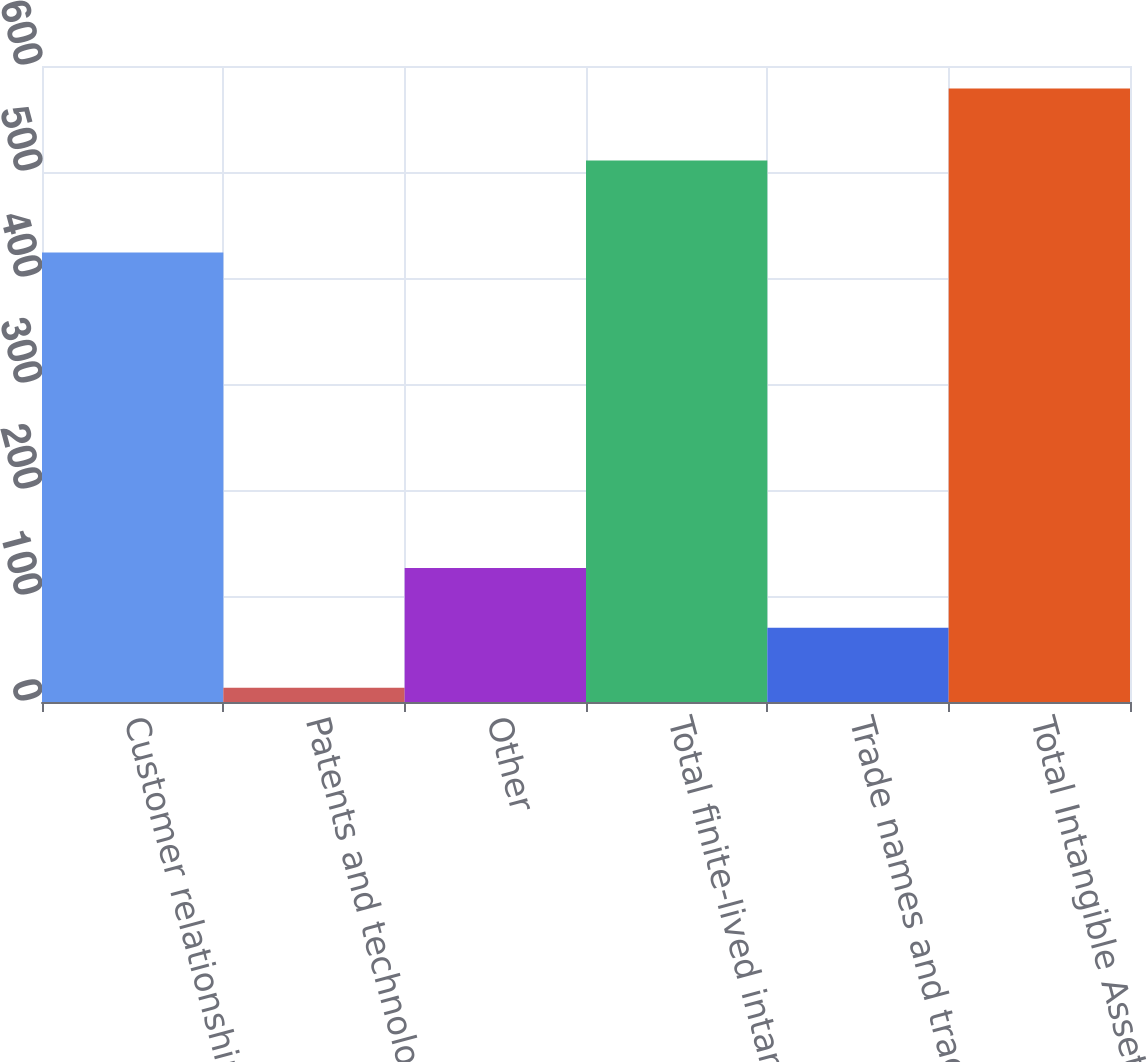Convert chart. <chart><loc_0><loc_0><loc_500><loc_500><bar_chart><fcel>Customer relationships<fcel>Patents and technology<fcel>Other<fcel>Total finite-lived intangibles<fcel>Trade names and trademarks<fcel>Total Intangible Assets<nl><fcel>424.1<fcel>13.4<fcel>126.46<fcel>510.9<fcel>69.93<fcel>578.7<nl></chart> 